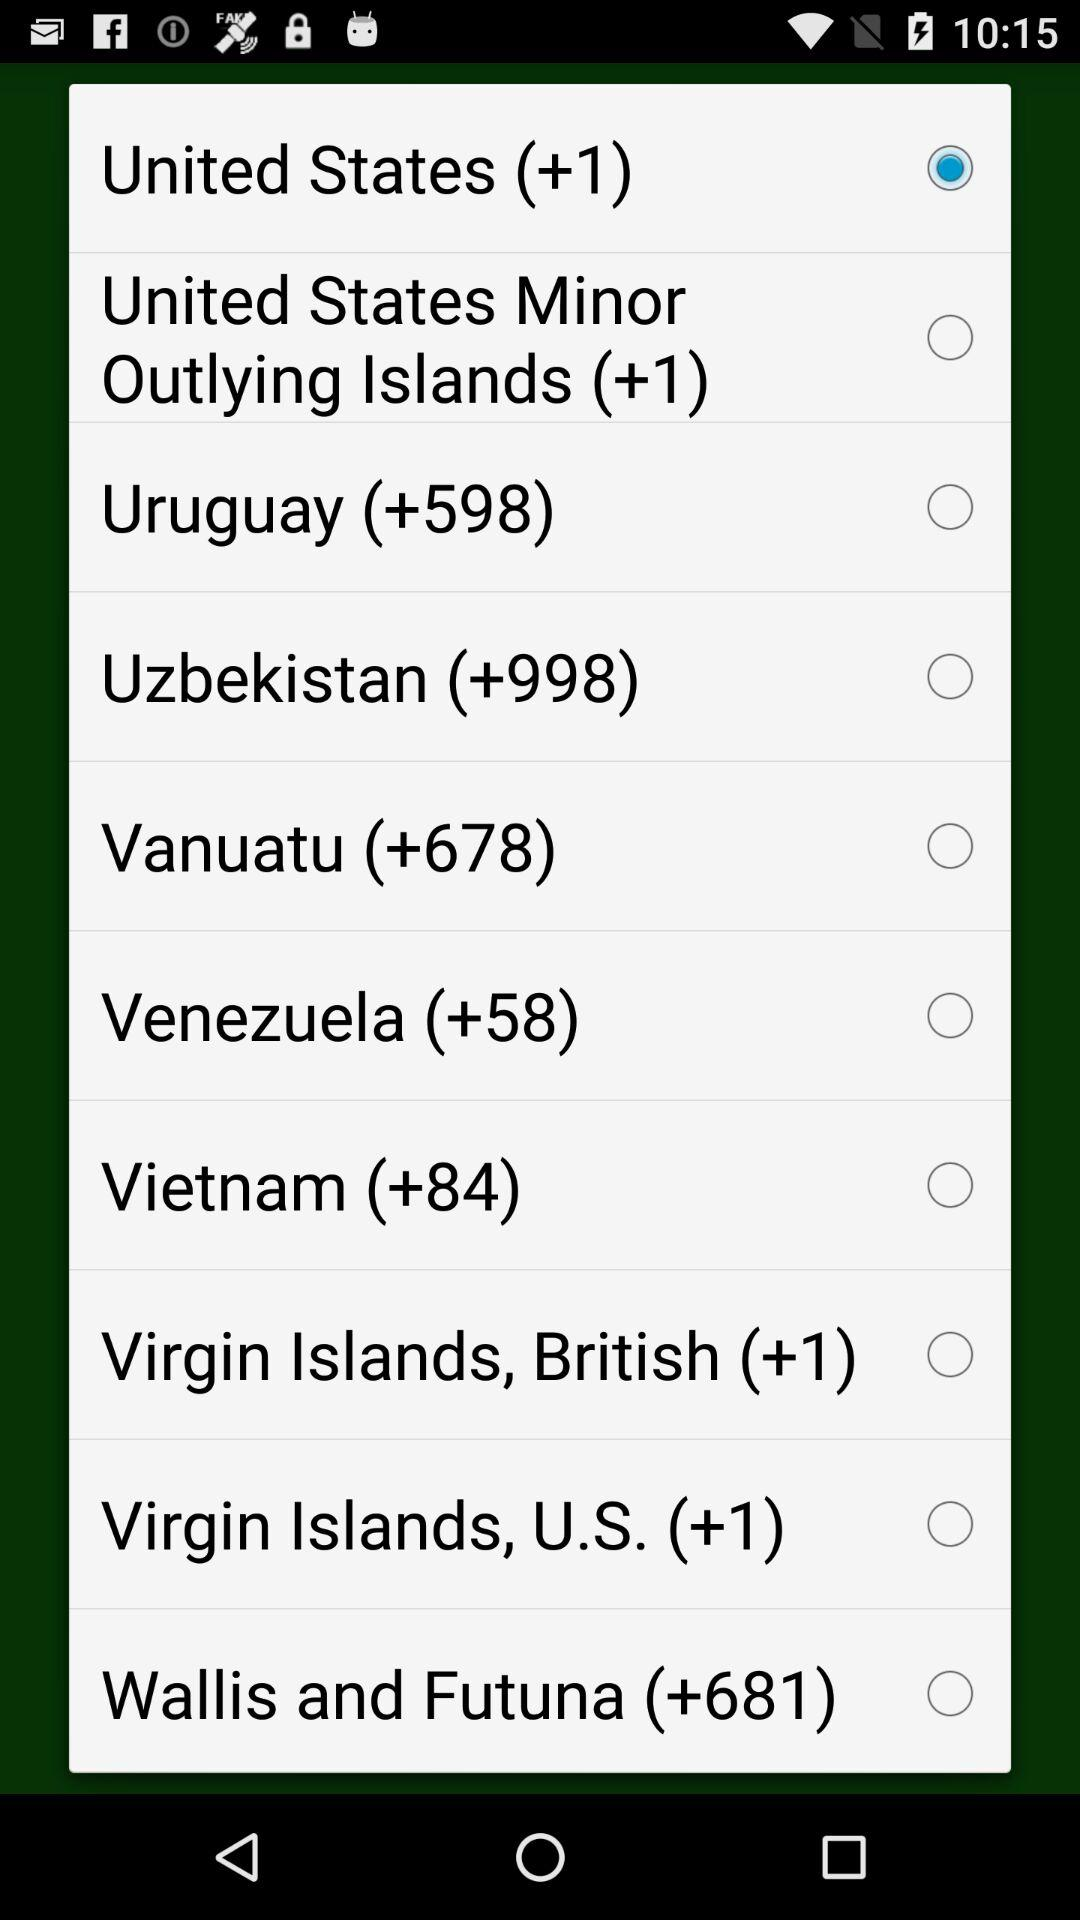Which option has been selected? The selected option is "United States (+1)". 